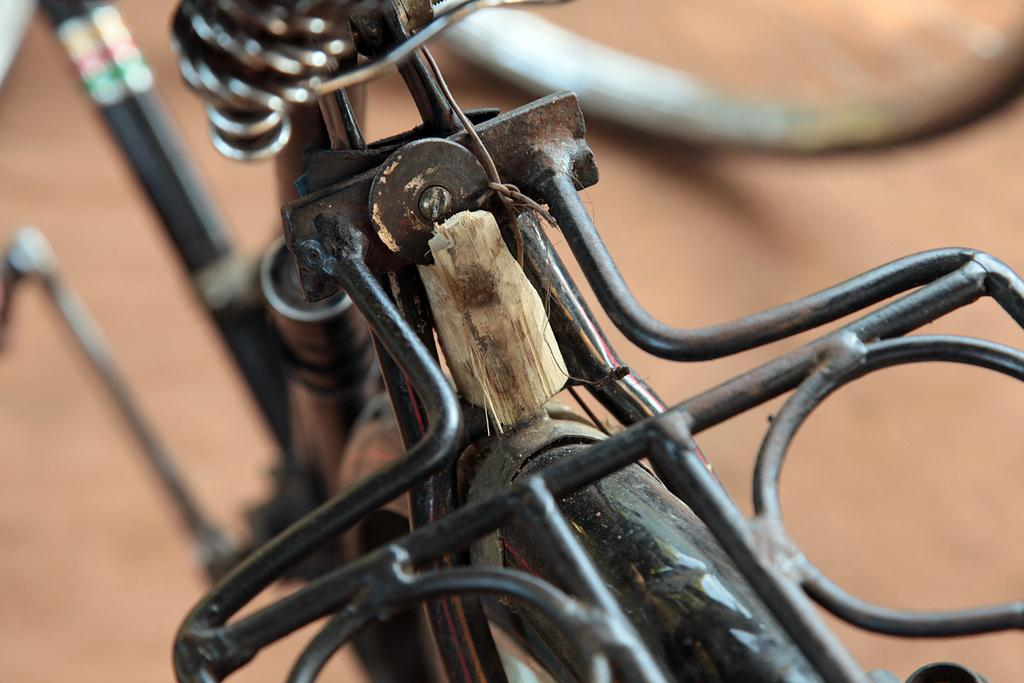What mode of transportation can be seen in the image? There is a bicycle present in the image. Where is the cushion placed in the image? There is no cushion present in the image. What type of pocket can be seen on the bicycle in the image? There is no pocket visible on the bicycle in the image. 